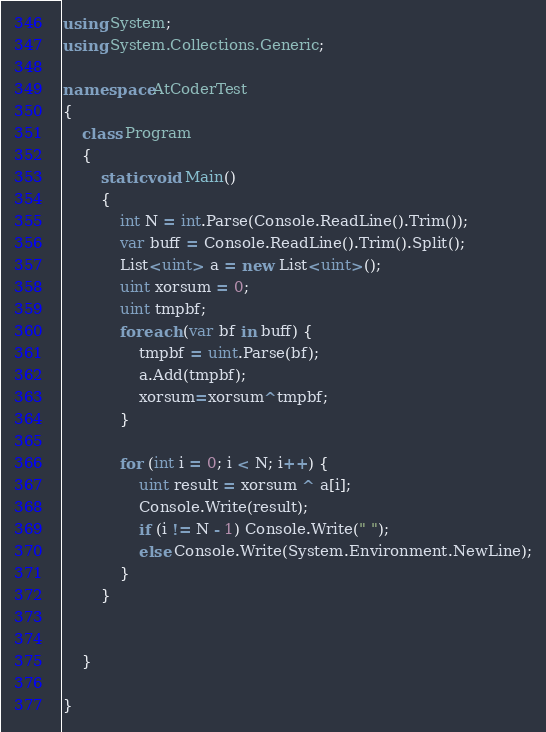<code> <loc_0><loc_0><loc_500><loc_500><_C#_>using System;
using System.Collections.Generic;

namespace AtCoderTest
{
    class Program
    {
        static void Main()
        {
            int N = int.Parse(Console.ReadLine().Trim());
            var buff = Console.ReadLine().Trim().Split();
            List<uint> a = new List<uint>();
            uint xorsum = 0;
            uint tmpbf;
            foreach (var bf in buff) {
                tmpbf = uint.Parse(bf);
                a.Add(tmpbf);
                xorsum=xorsum^tmpbf;
            }

            for (int i = 0; i < N; i++) {
                uint result = xorsum ^ a[i];
                Console.Write(result);
                if (i != N - 1) Console.Write(" ");
                else Console.Write(System.Environment.NewLine);
            }
        }


    }

}
</code> 